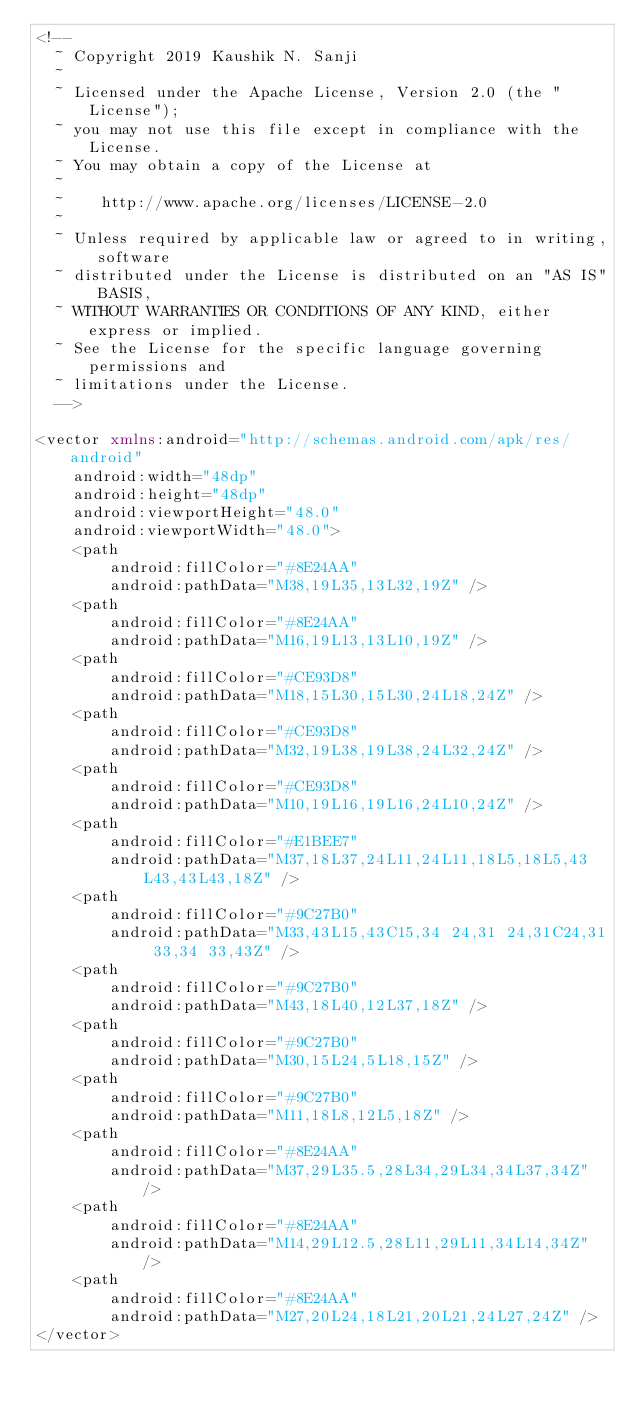Convert code to text. <code><loc_0><loc_0><loc_500><loc_500><_XML_><!--
  ~ Copyright 2019 Kaushik N. Sanji
  ~
  ~ Licensed under the Apache License, Version 2.0 (the "License");
  ~ you may not use this file except in compliance with the License.
  ~ You may obtain a copy of the License at
  ~
  ~    http://www.apache.org/licenses/LICENSE-2.0
  ~
  ~ Unless required by applicable law or agreed to in writing, software
  ~ distributed under the License is distributed on an "AS IS" BASIS,
  ~ WITHOUT WARRANTIES OR CONDITIONS OF ANY KIND, either express or implied.
  ~ See the License for the specific language governing permissions and
  ~ limitations under the License.
  -->

<vector xmlns:android="http://schemas.android.com/apk/res/android"
    android:width="48dp"
    android:height="48dp"
    android:viewportHeight="48.0"
    android:viewportWidth="48.0">
    <path
        android:fillColor="#8E24AA"
        android:pathData="M38,19L35,13L32,19Z" />
    <path
        android:fillColor="#8E24AA"
        android:pathData="M16,19L13,13L10,19Z" />
    <path
        android:fillColor="#CE93D8"
        android:pathData="M18,15L30,15L30,24L18,24Z" />
    <path
        android:fillColor="#CE93D8"
        android:pathData="M32,19L38,19L38,24L32,24Z" />
    <path
        android:fillColor="#CE93D8"
        android:pathData="M10,19L16,19L16,24L10,24Z" />
    <path
        android:fillColor="#E1BEE7"
        android:pathData="M37,18L37,24L11,24L11,18L5,18L5,43L43,43L43,18Z" />
    <path
        android:fillColor="#9C27B0"
        android:pathData="M33,43L15,43C15,34 24,31 24,31C24,31 33,34 33,43Z" />
    <path
        android:fillColor="#9C27B0"
        android:pathData="M43,18L40,12L37,18Z" />
    <path
        android:fillColor="#9C27B0"
        android:pathData="M30,15L24,5L18,15Z" />
    <path
        android:fillColor="#9C27B0"
        android:pathData="M11,18L8,12L5,18Z" />
    <path
        android:fillColor="#8E24AA"
        android:pathData="M37,29L35.5,28L34,29L34,34L37,34Z" />
    <path
        android:fillColor="#8E24AA"
        android:pathData="M14,29L12.5,28L11,29L11,34L14,34Z" />
    <path
        android:fillColor="#8E24AA"
        android:pathData="M27,20L24,18L21,20L21,24L27,24Z" />
</vector>
</code> 